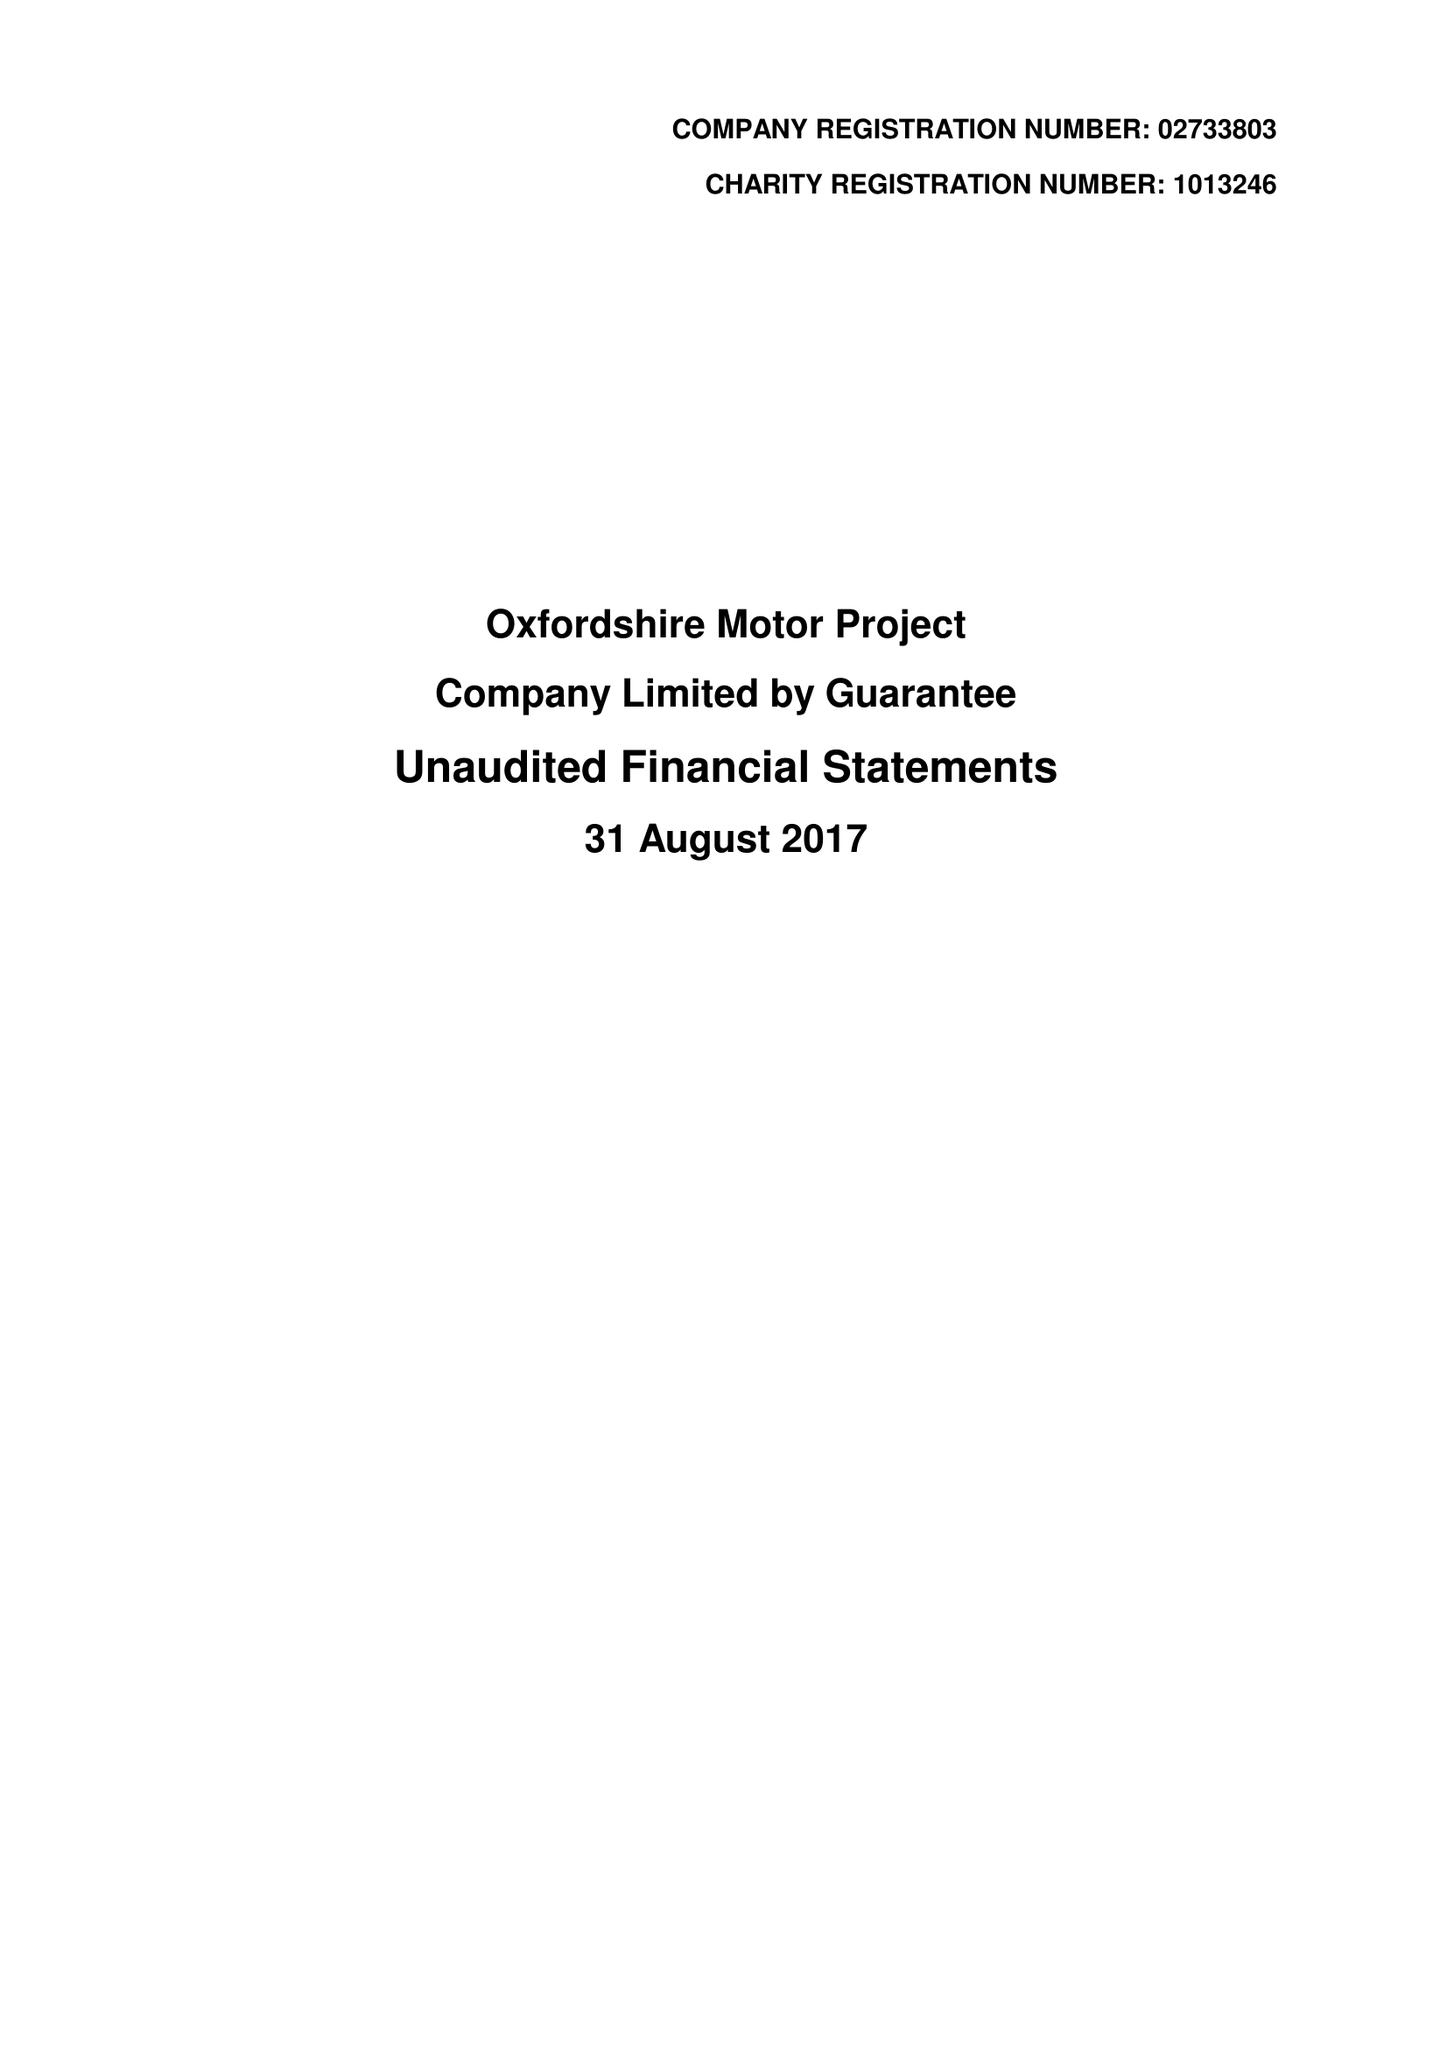What is the value for the address__street_line?
Answer the question using a single word or phrase. WOODSTOCK ROAD 